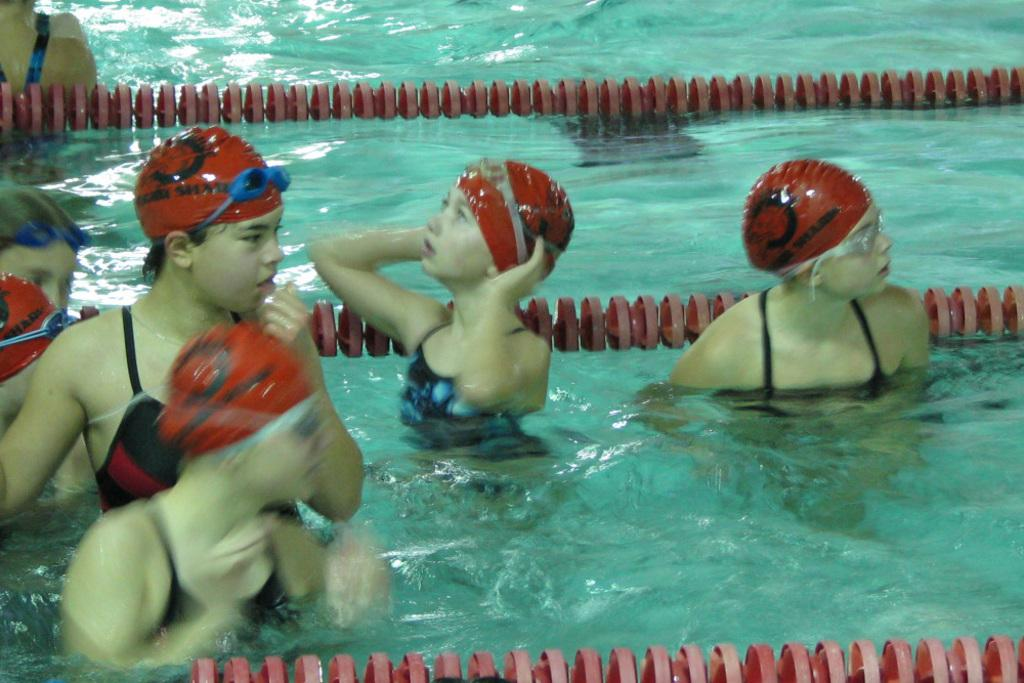What are the children doing in the image? The children are in a swimming pool in the image. What are the children wearing on their heads? The children are wearing caps and spectacles on their heads. What can be seen in the background of the image? There is water visible in the background of the image. What type of act can be seen the children performing in the image? There is no act being performed by the children in the image; they are simply swimming and wearing caps and spectacles. 